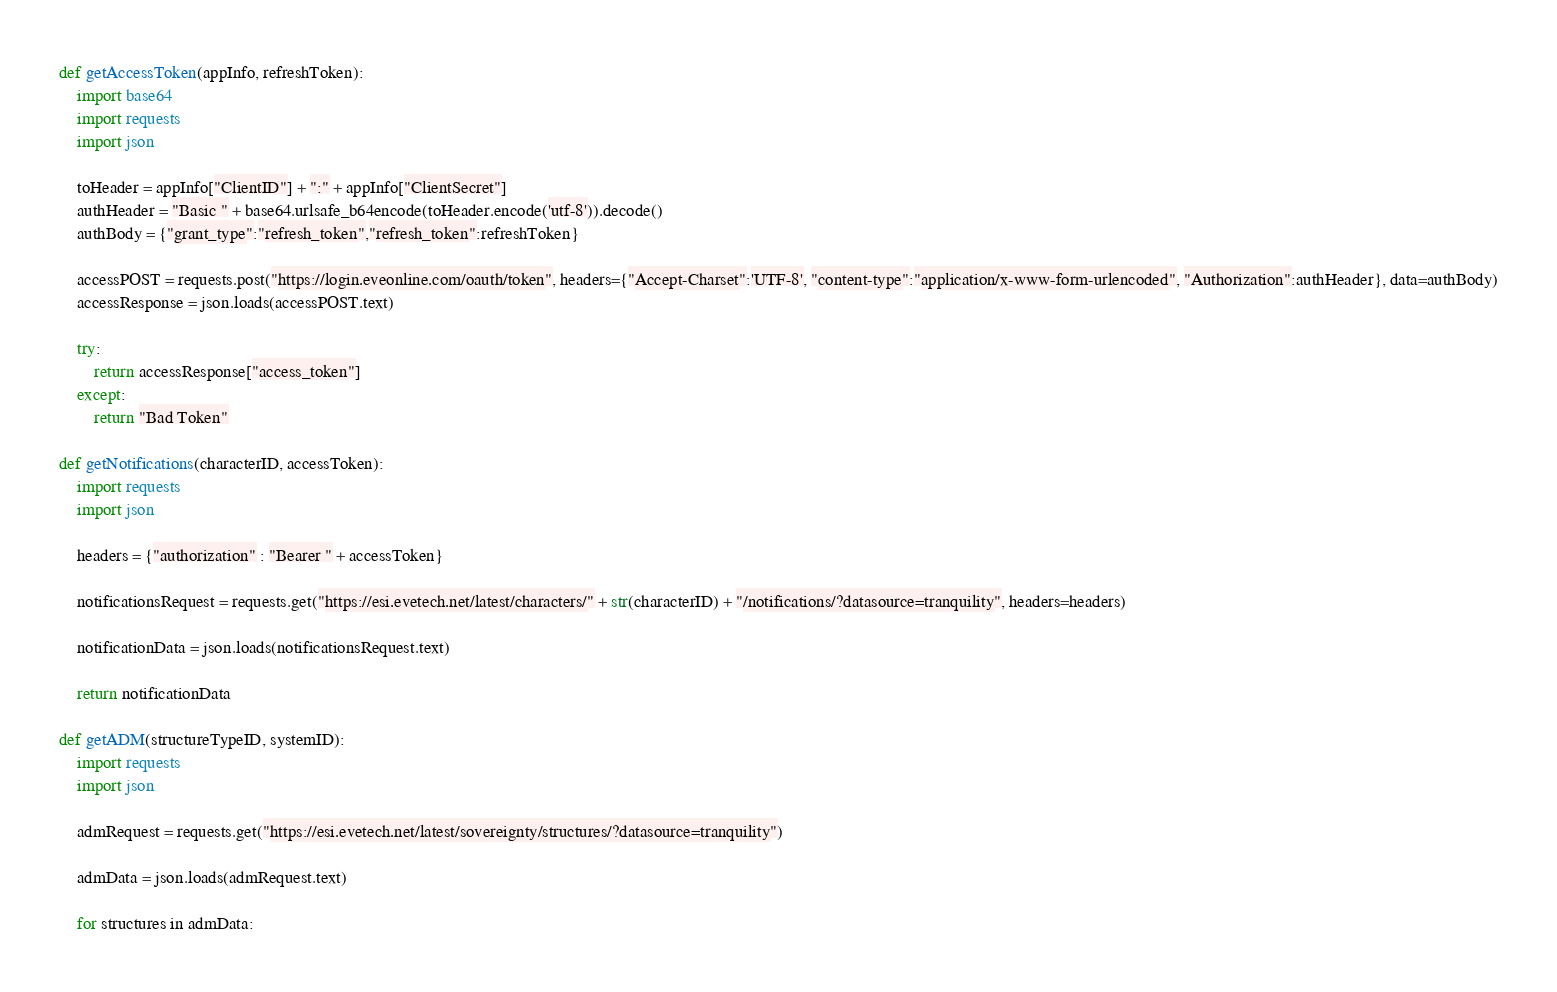<code> <loc_0><loc_0><loc_500><loc_500><_Python_>def getAccessToken(appInfo, refreshToken):
    import base64
    import requests
    import json

    toHeader = appInfo["ClientID"] + ":" + appInfo["ClientSecret"]
    authHeader = "Basic " + base64.urlsafe_b64encode(toHeader.encode('utf-8')).decode()
    authBody = {"grant_type":"refresh_token","refresh_token":refreshToken}

    accessPOST = requests.post("https://login.eveonline.com/oauth/token", headers={"Accept-Charset":'UTF-8', "content-type":"application/x-www-form-urlencoded", "Authorization":authHeader}, data=authBody)
    accessResponse = json.loads(accessPOST.text)
    
    try:
        return accessResponse["access_token"]
    except:
        return "Bad Token"
        
def getNotifications(characterID, accessToken):
    import requests
    import json
    
    headers = {"authorization" : "Bearer " + accessToken}

    notificationsRequest = requests.get("https://esi.evetech.net/latest/characters/" + str(characterID) + "/notifications/?datasource=tranquility", headers=headers)
    
    notificationData = json.loads(notificationsRequest.text)
    
    return notificationData

def getADM(structureTypeID, systemID):
    import requests
    import json

    admRequest = requests.get("https://esi.evetech.net/latest/sovereignty/structures/?datasource=tranquility")
    
    admData = json.loads(admRequest.text)
    
    for structures in admData:</code> 